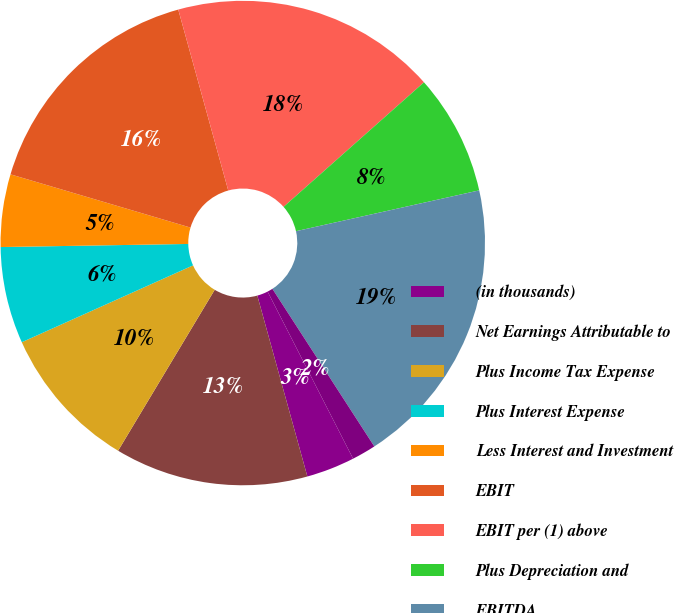<chart> <loc_0><loc_0><loc_500><loc_500><pie_chart><fcel>(in thousands)<fcel>Net Earnings Attributable to<fcel>Plus Income Tax Expense<fcel>Plus Interest Expense<fcel>Less Interest and Investment<fcel>EBIT<fcel>EBIT per (1) above<fcel>Plus Depreciation and<fcel>EBITDA<fcel>X (1 - Effective Tax Rate)<nl><fcel>3.23%<fcel>12.9%<fcel>9.68%<fcel>6.45%<fcel>4.84%<fcel>16.13%<fcel>17.74%<fcel>8.06%<fcel>19.35%<fcel>1.61%<nl></chart> 